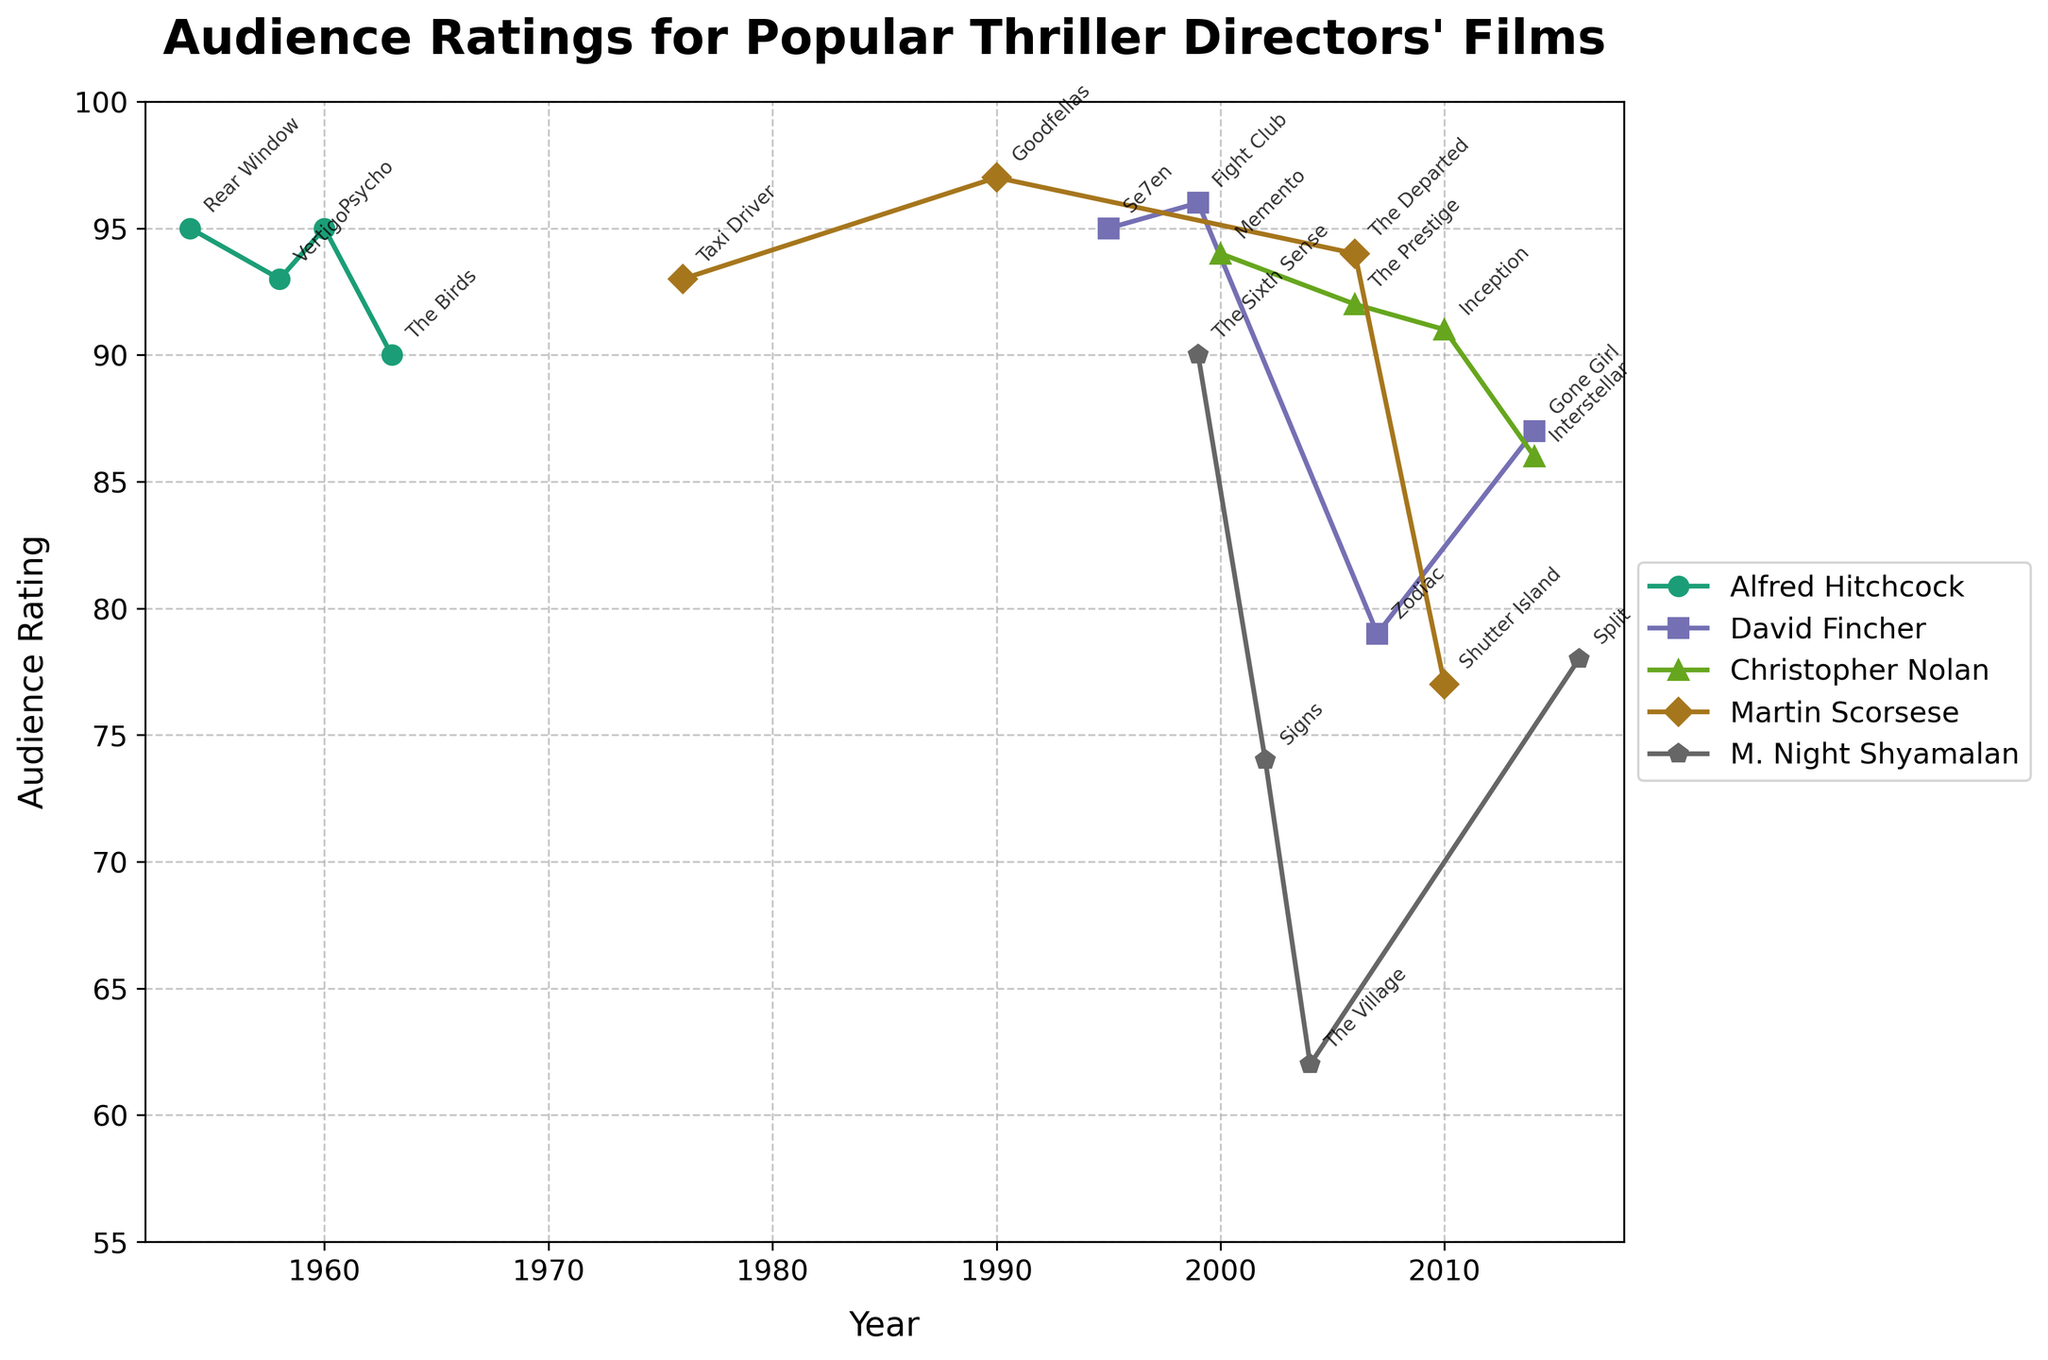Which director has the most films with an audience rating above 90? From the plot, count the number of films each director has with audience ratings above 90. Alfred Hitchcock has 3 (Rear Window, Vertigo, Psycho), Christopher Nolan has 3 (Memento, The Prestige, Inception), and Martin Scorsese has 2 (Taxi Driver, Goodfellas). David Fincher has 2 (Se7en, Fight Club), and M. Night Shyamalan has 1 (The Sixth Sense). So, Alfred Hitchcock and Christopher Nolan both have 3 films with ratings above 90.
Answer: Alfred Hitchcock and Christopher Nolan Which film and director received the highest audience rating? Check the highest value on the y-axis which is 97 and then look at the corresponding movie label and director. Martin Scorsese's film Goodfellas received the highest rating at 97.
Answer: Goodfellas, Martin Scorsese What is the average audience rating for Alfred Hitchcock's films? List Alfred Hitchcock's films' ratings: 95 (Rear Window), 93 (Vertigo), 95 (Psycho), 90 (The Birds). The average is calculated as (95 + 93 + 95 + 90) / 4 = 373 / 4 = 93.25
Answer: 93.25 Which director had a film released in the earliest year, and what is the audience rating for that film? Identify the earliest year on the x-axis, which is 1954, and find the film and director corresponding to that year. The film is Rear Window by Alfred Hitchcock with an audience rating of 95.
Answer: Alfred Hitchcock, 95 How many directors have their lowest-rated film above 75? Identify the lowest rating for each director from the plot. Alfred Hitchcock's lowest is 90, David Fincher's lowest is 79, Christopher Nolan's lowest is 86, Martin Scorsese's lowest is 77, and M. Night Shyamalan's lowest is 62. Only Alfred Hitchcock and Christopher Nolan have their lowest-rated films above 75.
Answer: 2 For M. Night Shyamalan, how much higher is the rating for 'The Sixth Sense' compared to 'The Village'? Find the ratings for both films: 'The Sixth Sense' (90) and 'The Village' (62). The difference is 90 - 62 = 28.
Answer: 28 Which director's film has the steepest drop in audience rating compared to their previous film? Look for the largest drop between consecutive points. David Fincher's 'Fight Club' (96) to 'Zodiac' (79) has the steepest drop of 96 - 79 = 17.
Answer: David Fincher What is the range of audience ratings for Christopher Nolan's films? Identify the highest and lowest ratings for Christopher Nolan's films: 'Memento' (94) and 'Interstellar' (86). The range is 94 - 86 = 8.
Answer: 8 Which director released the most films between 2000 and 2010? Check the number of films released by each director within the given period. Christopher Nolan has 3 films (Memento - 2000, The Prestige - 2006, Inception - 2010). Other directors have fewer films within this period.
Answer: Christopher Nolan 